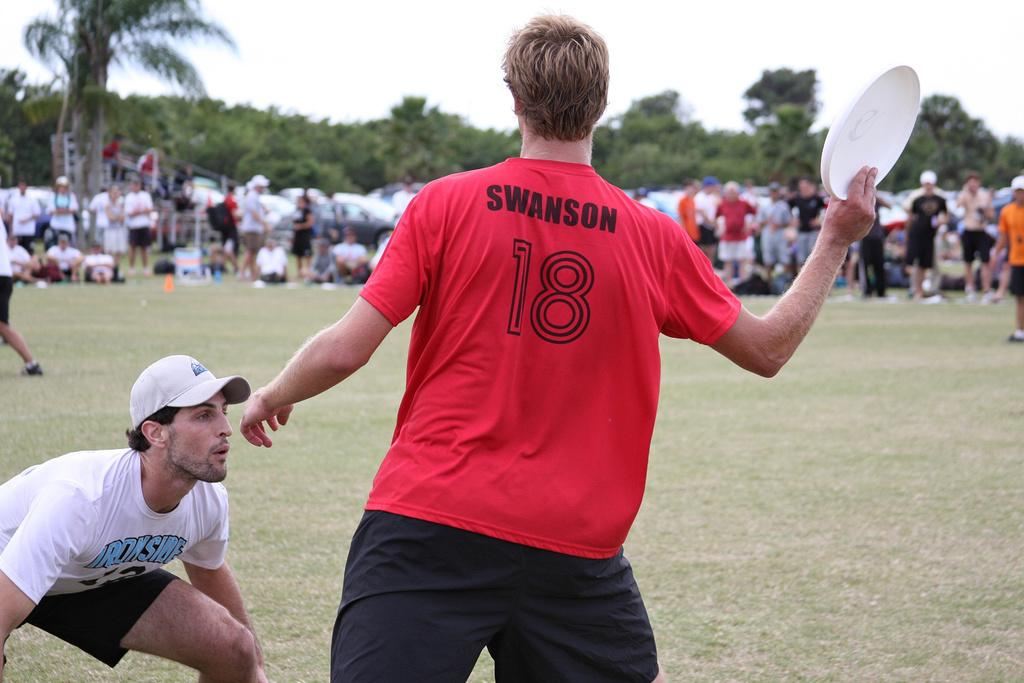How many people are present in the image? There are two people in the image. What is one of the people holding? One person is holding a Frisbee. What can be seen in the background of the image? There is a group of people and trees visible in the background. What else is visible in the background of the image? The sky is also visible in the background of the image. What type of flesh can be seen on the person holding the Frisbee? There is no flesh visible on the person holding the Frisbee in the image. 